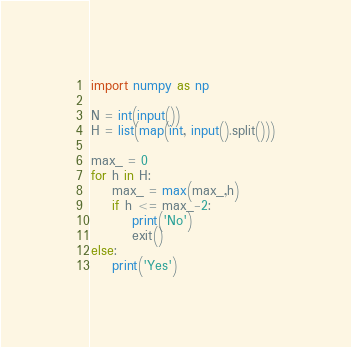<code> <loc_0><loc_0><loc_500><loc_500><_Python_>import numpy as np

N = int(input())
H = list(map(int, input().split()))

max_ = 0
for h in H:
    max_ = max(max_,h)
    if h <= max_-2:
        print('No')
        exit()
else:
    print('Yes')
</code> 